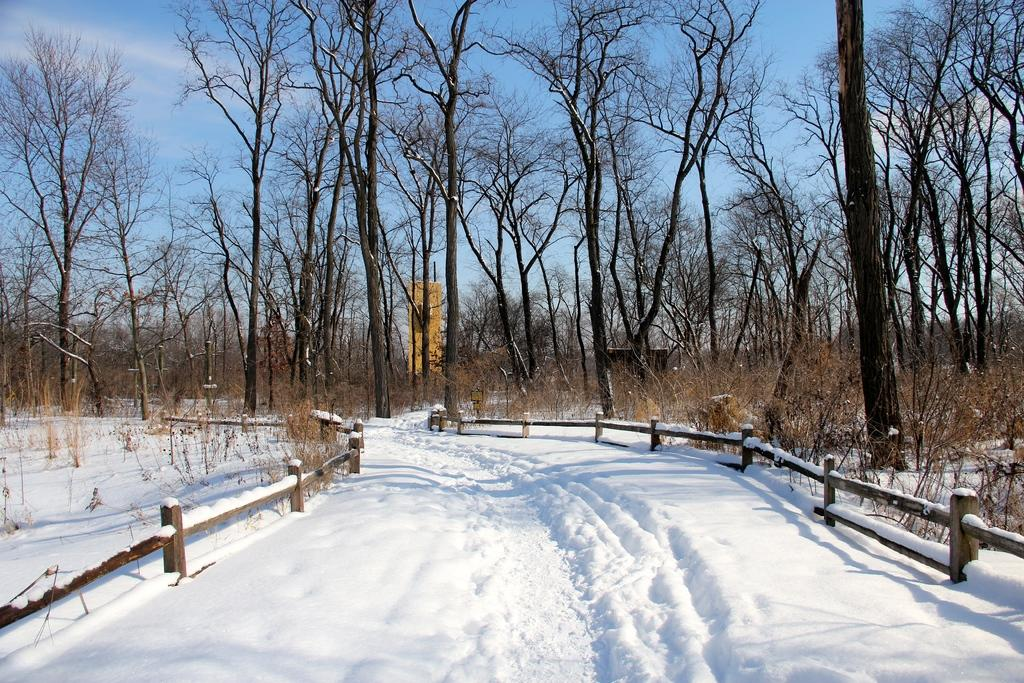What type of weather is depicted in the image? There is snow in the image, indicating a winter scene. What type of structure can be seen in the image? There is a wooden fence in the image. What can be seen in the distance in the image? There are trees in the background of the image. What is visible in the sky in the image? The sky is visible in the background of the image. What type of news is being reported by the police officer in the image? There are no police officers or news reports present in the image; it features snow, a wooden fence, trees, and the sky. 